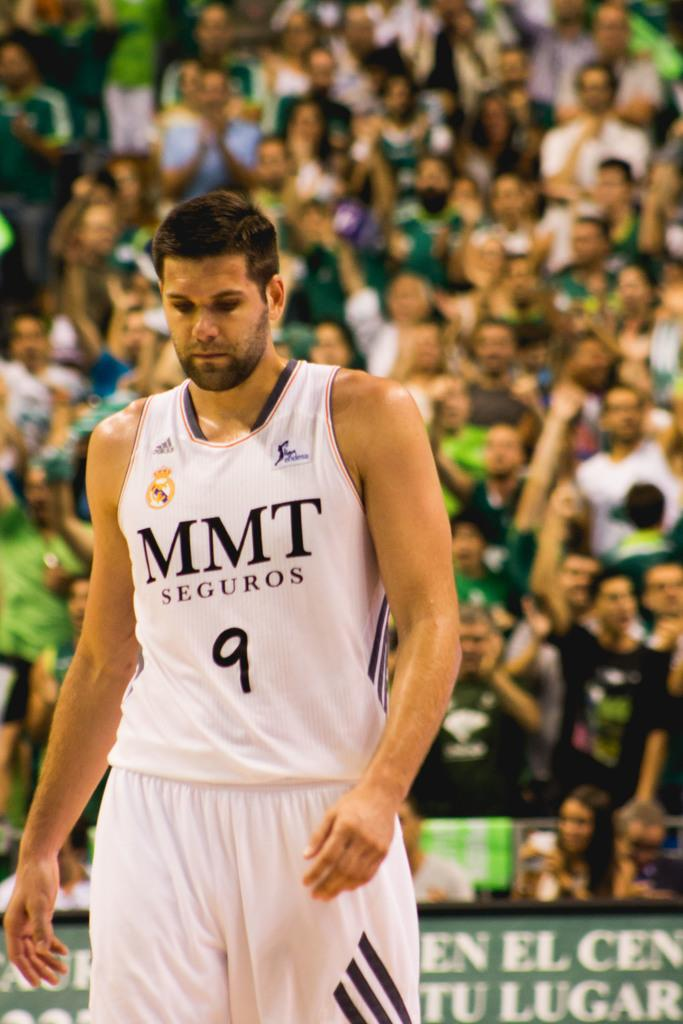<image>
Give a short and clear explanation of the subsequent image. Basketball player wearing a jersey that says MMT on it. 